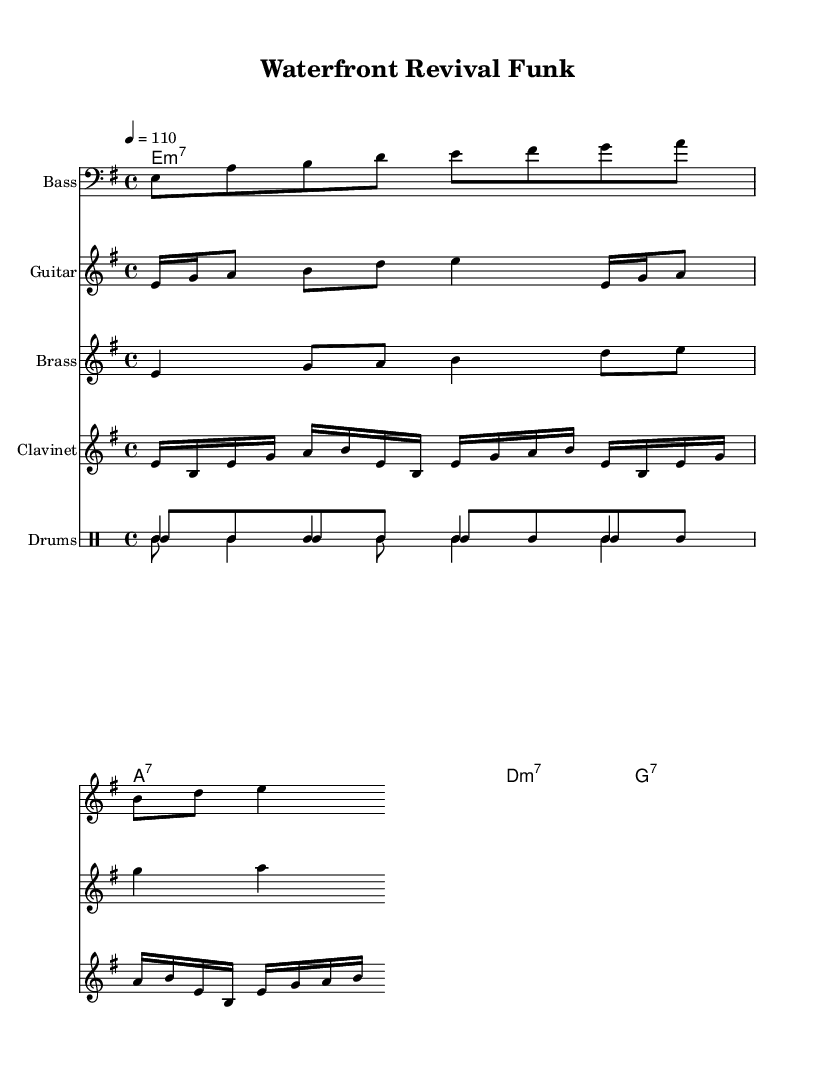What is the key signature of this music? The key signature is indicated by the set of sharps or flats at the beginning of the staff. In this piece, there are no sharps or flats, indicating it's in E minor.
Answer: E minor What is the time signature of this music? The time signature is usually indicated at the beginning of the staff as two numbers stacked vertically. Here, it shows 4/4, meaning there are four beats in each measure, and the quarter note gets one beat.
Answer: 4/4 What is the tempo marking for this piece? The tempo marking is located near the beginning, indicating the speed of the music. In this case, it states "4 = 110," which suggests 110 beats per minute for each quarter note.
Answer: 110 How many measures are in the main bass line? To find the number of measures, count the groupings of beats present in the bass line. Each measure contains four beats as per the 4/4 time signature. The visible bass line contains 4 measures in total.
Answer: 4 What chord is played in the first measure? The chord names are listed above the staff. In the first measure, the chord indicated is E minor 7 (em7), shown as "em7" directly above the bass notes.
Answer: E minor 7 What is the primary instrument used for rhythmic support in this piece? The rhythmic support in funk typically comes from the drums, which are notated in a separate drum staff with a specific rhythmic pattern. Here, the drum staff is clearly marked, indicating the use of drums for rhythm.
Answer: Drums Which instrument plays the guitar riff? The instrument that performs the guitar riff is explicitly mentioned in the staff designation. It states "Guitar" under the corresponding staff, indicating the guitar section of the arrangement.
Answer: Guitar 